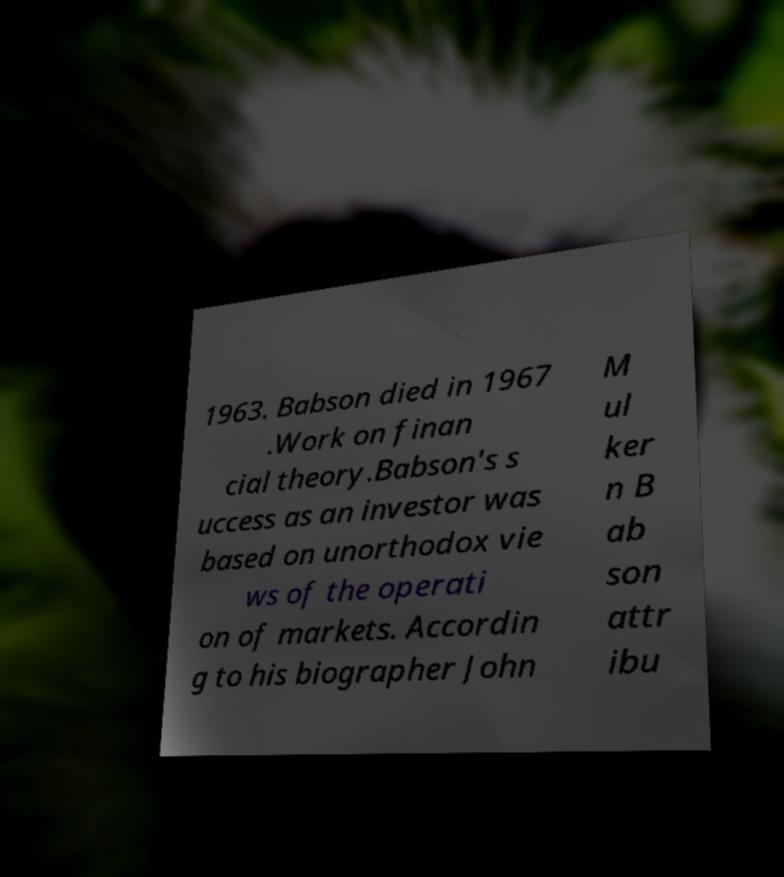Could you extract and type out the text from this image? 1963. Babson died in 1967 .Work on finan cial theory.Babson's s uccess as an investor was based on unorthodox vie ws of the operati on of markets. Accordin g to his biographer John M ul ker n B ab son attr ibu 